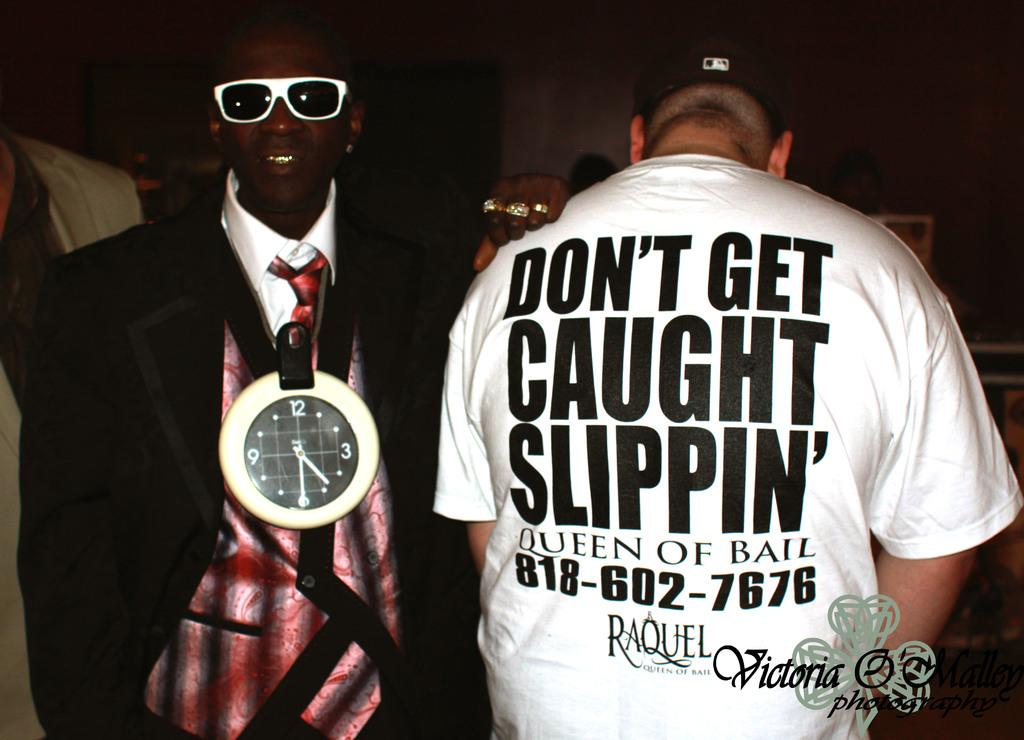<image>
Relay a brief, clear account of the picture shown. Two men, one of which has a shirt with the words don't get caught slippin' written on its back. 